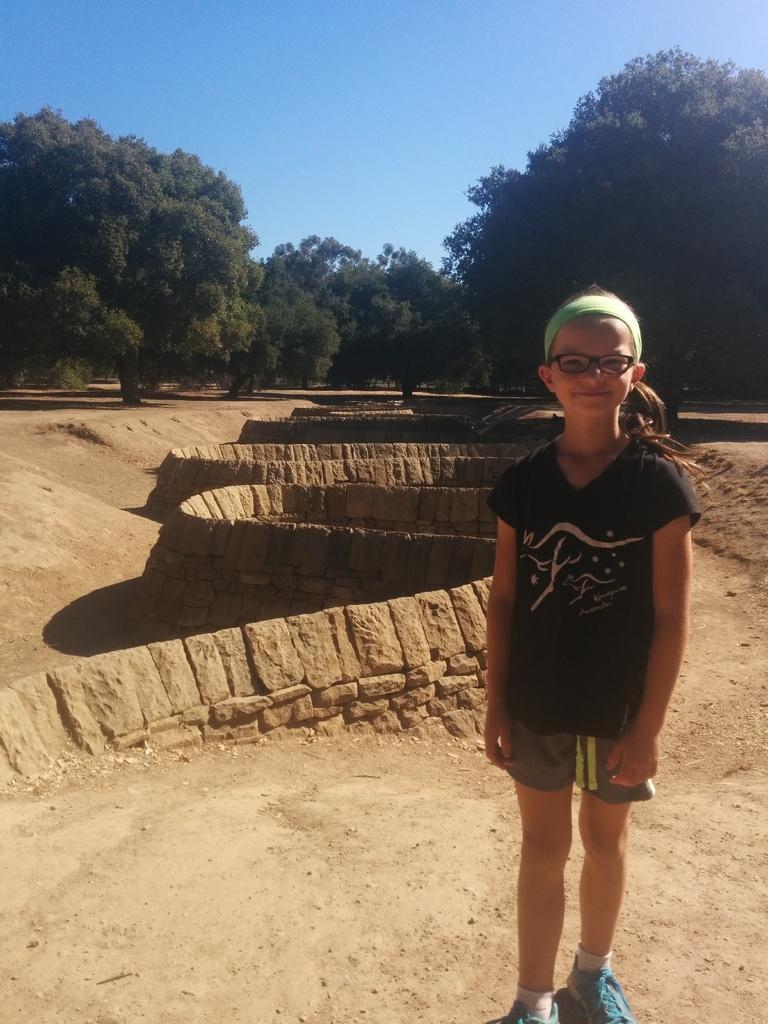How would you summarize this image in a sentence or two? There is a girl standing and smiling and we can see wall. In the background we can see trees and sky in blue color. 